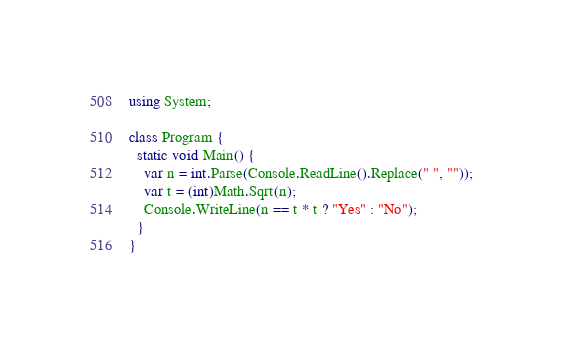Convert code to text. <code><loc_0><loc_0><loc_500><loc_500><_C#_>using System;

class Program {
  static void Main() {
    var n = int.Parse(Console.ReadLine().Replace(" ", ""));
    var t = (int)Math.Sqrt(n);
    Console.WriteLine(n == t * t ? "Yes" : "No");
  }
}</code> 